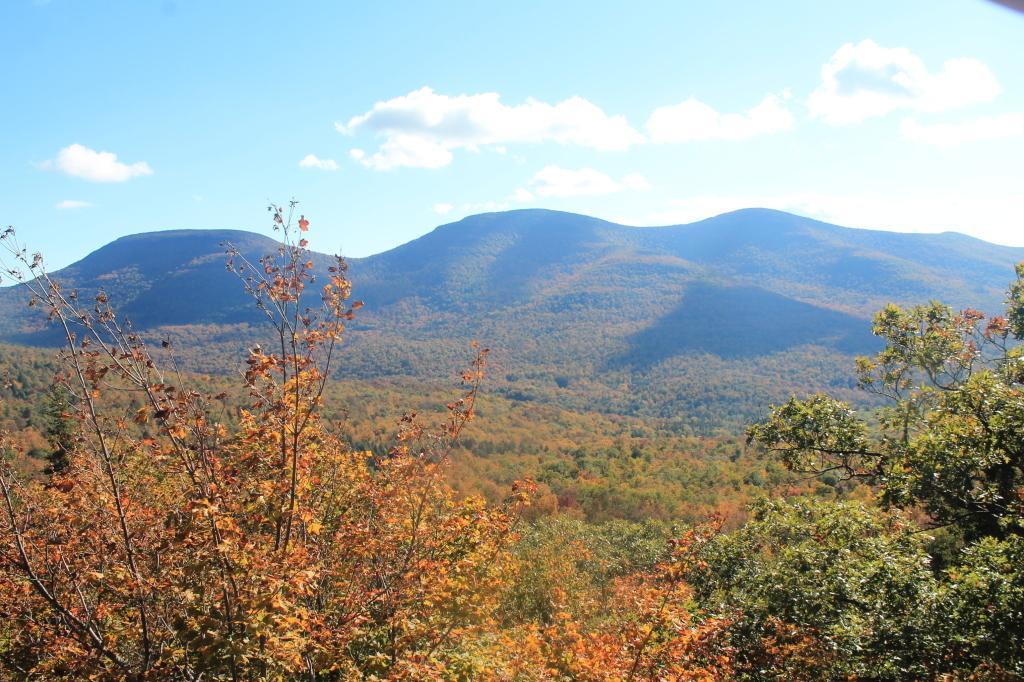Describe this image in one or two sentences. These are green color trees and a sky. 